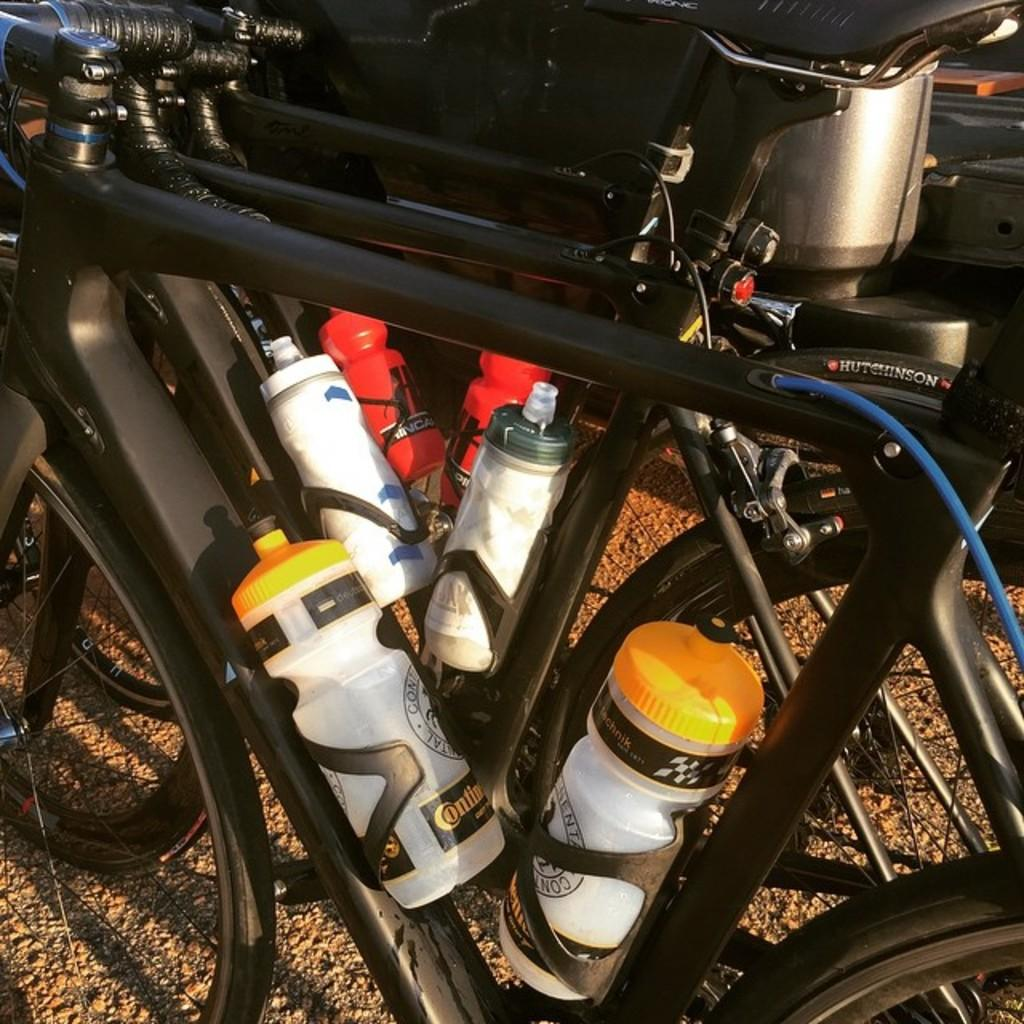What is the main subject of the image? The main subject of the image is a group of bicycles. How are the bicycles positioned in the image? The bicycles are placed on the ground. What else can be seen on the ground near the bicycles? There are bottles on the ground near the bicycles. Can you describe the steel device visible in the image? Unfortunately, the facts provided do not give any information about the steel device, so we cannot describe it. What type of jelly is being served in the basin in the image? There is no basin or jelly present in the image; it features a group of bicycles placed on the ground with bottles nearby. 